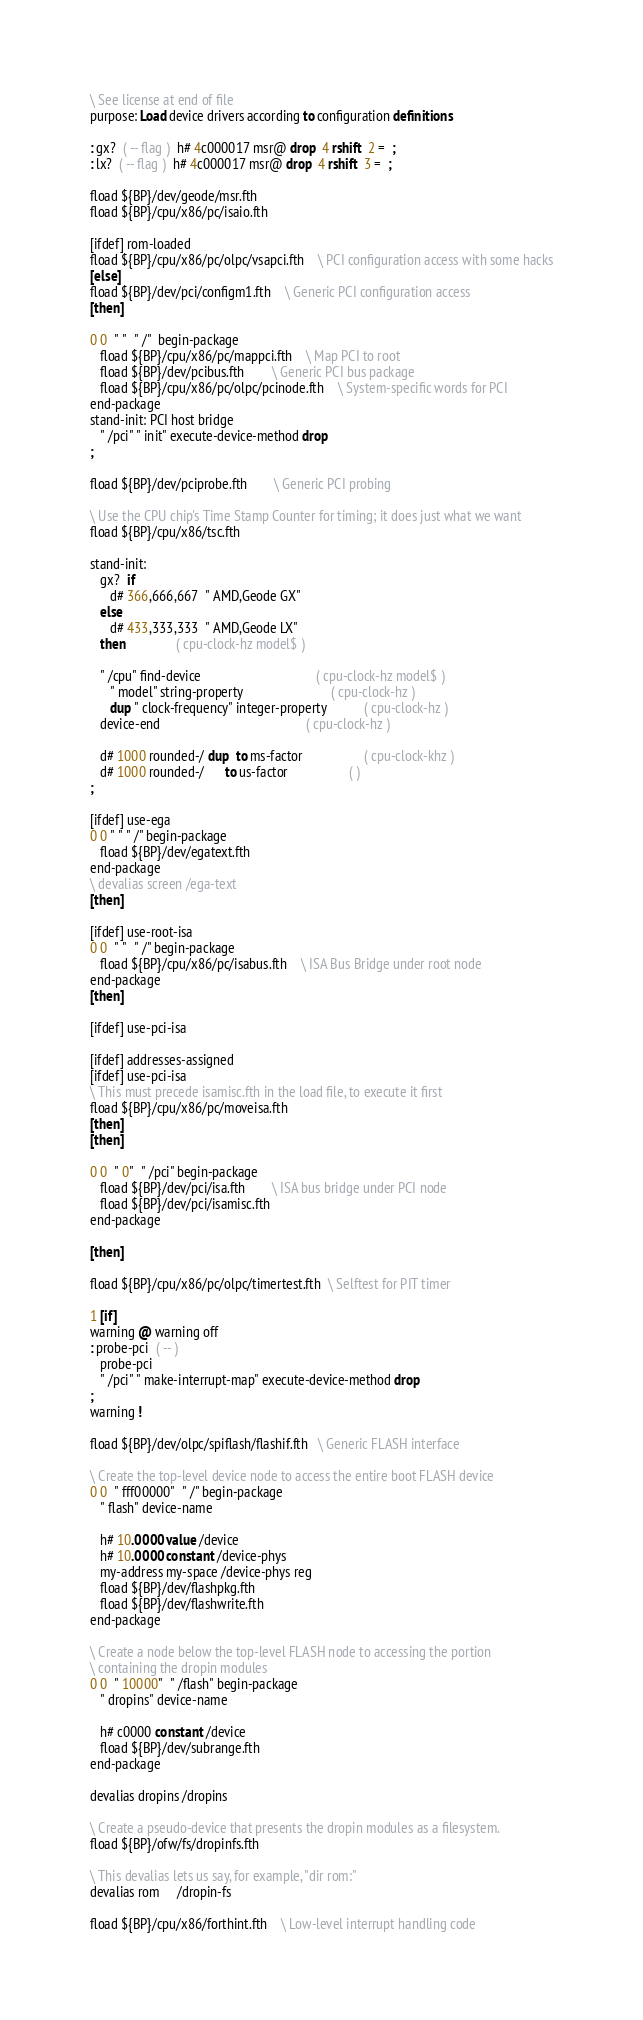Convert code to text. <code><loc_0><loc_0><loc_500><loc_500><_Forth_>\ See license at end of file
purpose: Load device drivers according to configuration definitions

: gx?  ( -- flag )  h# 4c000017 msr@ drop  4 rshift  2 =  ;
: lx?  ( -- flag )  h# 4c000017 msr@ drop  4 rshift  3 =  ;

fload ${BP}/dev/geode/msr.fth
fload ${BP}/cpu/x86/pc/isaio.fth

[ifdef] rom-loaded
fload ${BP}/cpu/x86/pc/olpc/vsapci.fth	\ PCI configuration access with some hacks
[else]
fload ${BP}/dev/pci/configm1.fth	\ Generic PCI configuration access
[then]

0 0  " "  " /"  begin-package
   fload ${BP}/cpu/x86/pc/mappci.fth	\ Map PCI to root
   fload ${BP}/dev/pcibus.fth		\ Generic PCI bus package
   fload ${BP}/cpu/x86/pc/olpc/pcinode.fth	\ System-specific words for PCI
end-package
stand-init: PCI host bridge
   " /pci" " init" execute-device-method drop
;

fload ${BP}/dev/pciprobe.fth		\ Generic PCI probing

\ Use the CPU chip's Time Stamp Counter for timing; it does just what we want
fload ${BP}/cpu/x86/tsc.fth

stand-init:
   gx?  if
      d# 366,666,667  " AMD,Geode GX"
   else
      d# 433,333,333  " AMD,Geode LX"
   then               ( cpu-clock-hz model$ )

   " /cpu" find-device                                  ( cpu-clock-hz model$ )
      " model" string-property                          ( cpu-clock-hz )
      dup " clock-frequency" integer-property           ( cpu-clock-hz )
   device-end                                           ( cpu-clock-hz )

   d# 1000 rounded-/ dup  to ms-factor                  ( cpu-clock-khz )
   d# 1000 rounded-/      to us-factor                  ( )
;

[ifdef] use-ega
0 0 " " " /" begin-package
   fload ${BP}/dev/egatext.fth
end-package
\ devalias screen /ega-text
[then]

[ifdef] use-root-isa
0 0  " "  " /" begin-package
   fload ${BP}/cpu/x86/pc/isabus.fth	\ ISA Bus Bridge under root node
end-package
[then]

[ifdef] use-pci-isa

[ifdef] addresses-assigned
[ifdef] use-pci-isa
\ This must precede isamisc.fth in the load file, to execute it first
fload ${BP}/cpu/x86/pc/moveisa.fth
[then]
[then]

0 0  " 0"  " /pci" begin-package
   fload ${BP}/dev/pci/isa.fth		\ ISA bus bridge under PCI node
   fload ${BP}/dev/pci/isamisc.fth
end-package

[then]

fload ${BP}/cpu/x86/pc/olpc/timertest.fth  \ Selftest for PIT timer

1 [if]
warning @ warning off
: probe-pci  ( -- )
   probe-pci
   " /pci" " make-interrupt-map" execute-device-method drop
;
warning !

fload ${BP}/dev/olpc/spiflash/flashif.fth   \ Generic FLASH interface

\ Create the top-level device node to access the entire boot FLASH device
0 0  " fff00000"  " /" begin-package
   " flash" device-name

   h# 10.0000 value /device
   h# 10.0000 constant /device-phys
   my-address my-space /device-phys reg
   fload ${BP}/dev/flashpkg.fth
   fload ${BP}/dev/flashwrite.fth
end-package

\ Create a node below the top-level FLASH node to accessing the portion
\ containing the dropin modules
0 0  " 10000"  " /flash" begin-package
   " dropins" device-name

   h# c0000 constant /device
   fload ${BP}/dev/subrange.fth
end-package

devalias dropins /dropins

\ Create a pseudo-device that presents the dropin modules as a filesystem.
fload ${BP}/ofw/fs/dropinfs.fth

\ This devalias lets us say, for example, "dir rom:"
devalias rom     /dropin-fs

fload ${BP}/cpu/x86/forthint.fth	\ Low-level interrupt handling code</code> 